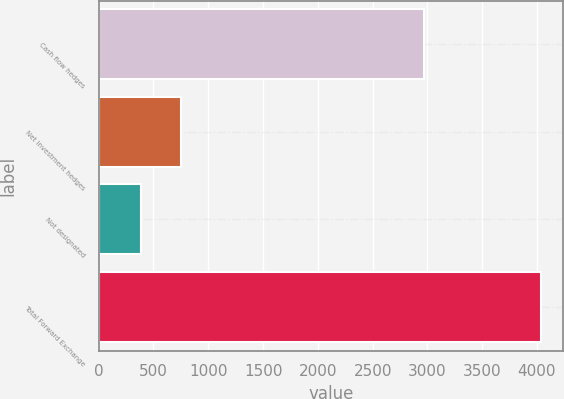Convert chart to OTSL. <chart><loc_0><loc_0><loc_500><loc_500><bar_chart><fcel>Cash flow hedges<fcel>Net investment hedges<fcel>Not designated<fcel>Total Forward Exchange<nl><fcel>2965.5<fcel>746.64<fcel>381.5<fcel>4032.9<nl></chart> 